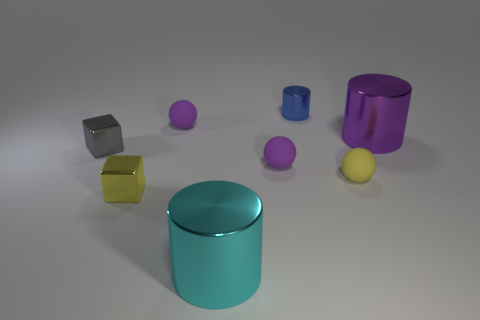What number of tiny blue metallic things are in front of the metal block behind the yellow block? There are no tiny blue metallic things in front of the metal block that is situated behind the yellow block in the image provided. 